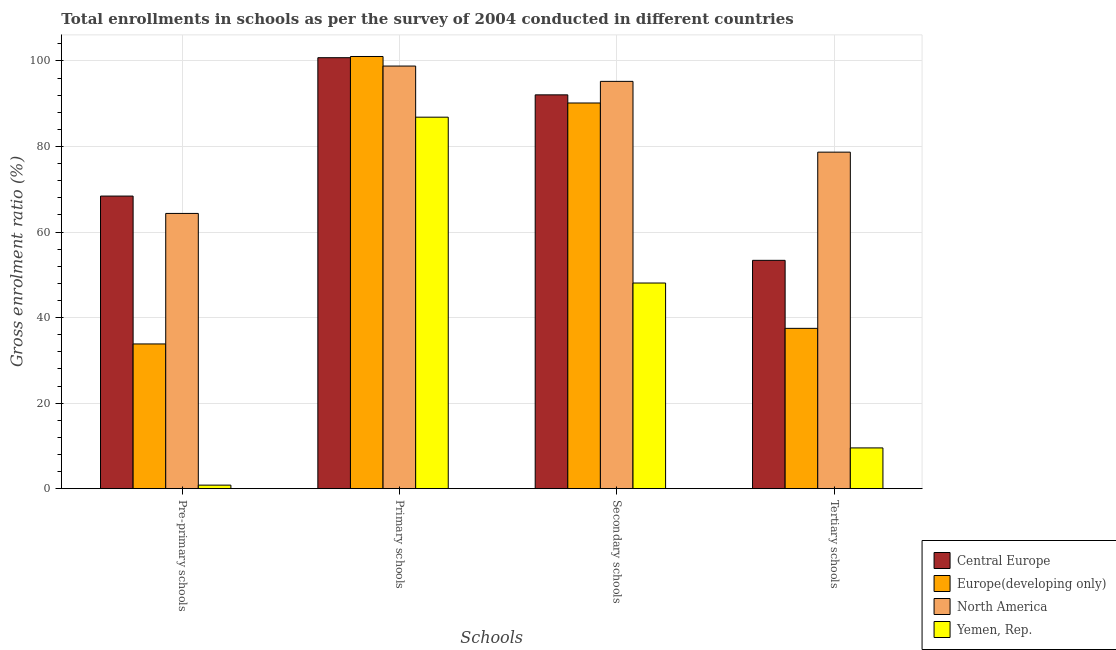How many different coloured bars are there?
Give a very brief answer. 4. Are the number of bars per tick equal to the number of legend labels?
Make the answer very short. Yes. Are the number of bars on each tick of the X-axis equal?
Provide a short and direct response. Yes. How many bars are there on the 2nd tick from the right?
Your answer should be compact. 4. What is the label of the 2nd group of bars from the left?
Your answer should be compact. Primary schools. What is the gross enrolment ratio in tertiary schools in Yemen, Rep.?
Make the answer very short. 9.53. Across all countries, what is the maximum gross enrolment ratio in pre-primary schools?
Ensure brevity in your answer.  68.41. Across all countries, what is the minimum gross enrolment ratio in primary schools?
Your response must be concise. 86.85. In which country was the gross enrolment ratio in primary schools maximum?
Your answer should be compact. Europe(developing only). In which country was the gross enrolment ratio in pre-primary schools minimum?
Your answer should be very brief. Yemen, Rep. What is the total gross enrolment ratio in pre-primary schools in the graph?
Give a very brief answer. 167.42. What is the difference between the gross enrolment ratio in pre-primary schools in Central Europe and that in Yemen, Rep.?
Your response must be concise. 67.58. What is the difference between the gross enrolment ratio in primary schools in Yemen, Rep. and the gross enrolment ratio in tertiary schools in North America?
Offer a very short reply. 8.17. What is the average gross enrolment ratio in pre-primary schools per country?
Offer a very short reply. 41.85. What is the difference between the gross enrolment ratio in secondary schools and gross enrolment ratio in primary schools in Central Europe?
Offer a very short reply. -8.69. In how many countries, is the gross enrolment ratio in secondary schools greater than 84 %?
Your response must be concise. 3. What is the ratio of the gross enrolment ratio in tertiary schools in Europe(developing only) to that in Yemen, Rep.?
Make the answer very short. 3.93. Is the gross enrolment ratio in pre-primary schools in North America less than that in Central Europe?
Your answer should be compact. Yes. What is the difference between the highest and the second highest gross enrolment ratio in tertiary schools?
Ensure brevity in your answer.  25.29. What is the difference between the highest and the lowest gross enrolment ratio in secondary schools?
Your answer should be compact. 47.14. Is it the case that in every country, the sum of the gross enrolment ratio in primary schools and gross enrolment ratio in secondary schools is greater than the sum of gross enrolment ratio in pre-primary schools and gross enrolment ratio in tertiary schools?
Keep it short and to the point. No. How many countries are there in the graph?
Your response must be concise. 4. What is the difference between two consecutive major ticks on the Y-axis?
Offer a very short reply. 20. Does the graph contain grids?
Ensure brevity in your answer.  Yes. How are the legend labels stacked?
Your response must be concise. Vertical. What is the title of the graph?
Make the answer very short. Total enrollments in schools as per the survey of 2004 conducted in different countries. What is the label or title of the X-axis?
Provide a succinct answer. Schools. What is the label or title of the Y-axis?
Keep it short and to the point. Gross enrolment ratio (%). What is the Gross enrolment ratio (%) in Central Europe in Pre-primary schools?
Your answer should be compact. 68.41. What is the Gross enrolment ratio (%) of Europe(developing only) in Pre-primary schools?
Make the answer very short. 33.84. What is the Gross enrolment ratio (%) in North America in Pre-primary schools?
Keep it short and to the point. 64.35. What is the Gross enrolment ratio (%) in Yemen, Rep. in Pre-primary schools?
Keep it short and to the point. 0.83. What is the Gross enrolment ratio (%) in Central Europe in Primary schools?
Provide a succinct answer. 100.76. What is the Gross enrolment ratio (%) in Europe(developing only) in Primary schools?
Your answer should be compact. 101.04. What is the Gross enrolment ratio (%) in North America in Primary schools?
Give a very brief answer. 98.8. What is the Gross enrolment ratio (%) in Yemen, Rep. in Primary schools?
Keep it short and to the point. 86.85. What is the Gross enrolment ratio (%) of Central Europe in Secondary schools?
Provide a succinct answer. 92.07. What is the Gross enrolment ratio (%) of Europe(developing only) in Secondary schools?
Your response must be concise. 90.17. What is the Gross enrolment ratio (%) in North America in Secondary schools?
Make the answer very short. 95.22. What is the Gross enrolment ratio (%) of Yemen, Rep. in Secondary schools?
Provide a succinct answer. 48.08. What is the Gross enrolment ratio (%) of Central Europe in Tertiary schools?
Keep it short and to the point. 53.38. What is the Gross enrolment ratio (%) in Europe(developing only) in Tertiary schools?
Offer a terse response. 37.48. What is the Gross enrolment ratio (%) of North America in Tertiary schools?
Make the answer very short. 78.68. What is the Gross enrolment ratio (%) of Yemen, Rep. in Tertiary schools?
Offer a terse response. 9.53. Across all Schools, what is the maximum Gross enrolment ratio (%) of Central Europe?
Give a very brief answer. 100.76. Across all Schools, what is the maximum Gross enrolment ratio (%) of Europe(developing only)?
Keep it short and to the point. 101.04. Across all Schools, what is the maximum Gross enrolment ratio (%) of North America?
Give a very brief answer. 98.8. Across all Schools, what is the maximum Gross enrolment ratio (%) in Yemen, Rep.?
Give a very brief answer. 86.85. Across all Schools, what is the minimum Gross enrolment ratio (%) of Central Europe?
Provide a succinct answer. 53.38. Across all Schools, what is the minimum Gross enrolment ratio (%) in Europe(developing only)?
Offer a terse response. 33.84. Across all Schools, what is the minimum Gross enrolment ratio (%) in North America?
Keep it short and to the point. 64.35. Across all Schools, what is the minimum Gross enrolment ratio (%) in Yemen, Rep.?
Offer a very short reply. 0.83. What is the total Gross enrolment ratio (%) in Central Europe in the graph?
Your answer should be compact. 314.62. What is the total Gross enrolment ratio (%) of Europe(developing only) in the graph?
Make the answer very short. 262.52. What is the total Gross enrolment ratio (%) of North America in the graph?
Offer a very short reply. 337.05. What is the total Gross enrolment ratio (%) in Yemen, Rep. in the graph?
Your response must be concise. 145.28. What is the difference between the Gross enrolment ratio (%) of Central Europe in Pre-primary schools and that in Primary schools?
Offer a very short reply. -32.35. What is the difference between the Gross enrolment ratio (%) in Europe(developing only) in Pre-primary schools and that in Primary schools?
Give a very brief answer. -67.2. What is the difference between the Gross enrolment ratio (%) of North America in Pre-primary schools and that in Primary schools?
Provide a short and direct response. -34.45. What is the difference between the Gross enrolment ratio (%) of Yemen, Rep. in Pre-primary schools and that in Primary schools?
Your response must be concise. -86.02. What is the difference between the Gross enrolment ratio (%) in Central Europe in Pre-primary schools and that in Secondary schools?
Your response must be concise. -23.66. What is the difference between the Gross enrolment ratio (%) in Europe(developing only) in Pre-primary schools and that in Secondary schools?
Make the answer very short. -56.33. What is the difference between the Gross enrolment ratio (%) in North America in Pre-primary schools and that in Secondary schools?
Give a very brief answer. -30.87. What is the difference between the Gross enrolment ratio (%) of Yemen, Rep. in Pre-primary schools and that in Secondary schools?
Your answer should be compact. -47.25. What is the difference between the Gross enrolment ratio (%) in Central Europe in Pre-primary schools and that in Tertiary schools?
Your response must be concise. 15.02. What is the difference between the Gross enrolment ratio (%) in Europe(developing only) in Pre-primary schools and that in Tertiary schools?
Your answer should be very brief. -3.65. What is the difference between the Gross enrolment ratio (%) in North America in Pre-primary schools and that in Tertiary schools?
Provide a short and direct response. -14.33. What is the difference between the Gross enrolment ratio (%) of Yemen, Rep. in Pre-primary schools and that in Tertiary schools?
Provide a short and direct response. -8.7. What is the difference between the Gross enrolment ratio (%) of Central Europe in Primary schools and that in Secondary schools?
Offer a very short reply. 8.69. What is the difference between the Gross enrolment ratio (%) in Europe(developing only) in Primary schools and that in Secondary schools?
Your response must be concise. 10.87. What is the difference between the Gross enrolment ratio (%) of North America in Primary schools and that in Secondary schools?
Your answer should be very brief. 3.58. What is the difference between the Gross enrolment ratio (%) of Yemen, Rep. in Primary schools and that in Secondary schools?
Provide a short and direct response. 38.77. What is the difference between the Gross enrolment ratio (%) of Central Europe in Primary schools and that in Tertiary schools?
Keep it short and to the point. 47.37. What is the difference between the Gross enrolment ratio (%) in Europe(developing only) in Primary schools and that in Tertiary schools?
Make the answer very short. 63.56. What is the difference between the Gross enrolment ratio (%) in North America in Primary schools and that in Tertiary schools?
Give a very brief answer. 20.13. What is the difference between the Gross enrolment ratio (%) in Yemen, Rep. in Primary schools and that in Tertiary schools?
Provide a short and direct response. 77.32. What is the difference between the Gross enrolment ratio (%) of Central Europe in Secondary schools and that in Tertiary schools?
Make the answer very short. 38.69. What is the difference between the Gross enrolment ratio (%) in Europe(developing only) in Secondary schools and that in Tertiary schools?
Give a very brief answer. 52.68. What is the difference between the Gross enrolment ratio (%) in North America in Secondary schools and that in Tertiary schools?
Your answer should be compact. 16.55. What is the difference between the Gross enrolment ratio (%) of Yemen, Rep. in Secondary schools and that in Tertiary schools?
Offer a terse response. 38.55. What is the difference between the Gross enrolment ratio (%) in Central Europe in Pre-primary schools and the Gross enrolment ratio (%) in Europe(developing only) in Primary schools?
Offer a very short reply. -32.63. What is the difference between the Gross enrolment ratio (%) in Central Europe in Pre-primary schools and the Gross enrolment ratio (%) in North America in Primary schools?
Keep it short and to the point. -30.4. What is the difference between the Gross enrolment ratio (%) in Central Europe in Pre-primary schools and the Gross enrolment ratio (%) in Yemen, Rep. in Primary schools?
Provide a succinct answer. -18.44. What is the difference between the Gross enrolment ratio (%) of Europe(developing only) in Pre-primary schools and the Gross enrolment ratio (%) of North America in Primary schools?
Your response must be concise. -64.97. What is the difference between the Gross enrolment ratio (%) of Europe(developing only) in Pre-primary schools and the Gross enrolment ratio (%) of Yemen, Rep. in Primary schools?
Your response must be concise. -53.01. What is the difference between the Gross enrolment ratio (%) of North America in Pre-primary schools and the Gross enrolment ratio (%) of Yemen, Rep. in Primary schools?
Offer a very short reply. -22.5. What is the difference between the Gross enrolment ratio (%) of Central Europe in Pre-primary schools and the Gross enrolment ratio (%) of Europe(developing only) in Secondary schools?
Provide a succinct answer. -21.76. What is the difference between the Gross enrolment ratio (%) of Central Europe in Pre-primary schools and the Gross enrolment ratio (%) of North America in Secondary schools?
Give a very brief answer. -26.82. What is the difference between the Gross enrolment ratio (%) of Central Europe in Pre-primary schools and the Gross enrolment ratio (%) of Yemen, Rep. in Secondary schools?
Ensure brevity in your answer.  20.33. What is the difference between the Gross enrolment ratio (%) of Europe(developing only) in Pre-primary schools and the Gross enrolment ratio (%) of North America in Secondary schools?
Provide a short and direct response. -61.39. What is the difference between the Gross enrolment ratio (%) in Europe(developing only) in Pre-primary schools and the Gross enrolment ratio (%) in Yemen, Rep. in Secondary schools?
Provide a succinct answer. -14.24. What is the difference between the Gross enrolment ratio (%) of North America in Pre-primary schools and the Gross enrolment ratio (%) of Yemen, Rep. in Secondary schools?
Your answer should be very brief. 16.27. What is the difference between the Gross enrolment ratio (%) of Central Europe in Pre-primary schools and the Gross enrolment ratio (%) of Europe(developing only) in Tertiary schools?
Offer a very short reply. 30.92. What is the difference between the Gross enrolment ratio (%) of Central Europe in Pre-primary schools and the Gross enrolment ratio (%) of North America in Tertiary schools?
Keep it short and to the point. -10.27. What is the difference between the Gross enrolment ratio (%) of Central Europe in Pre-primary schools and the Gross enrolment ratio (%) of Yemen, Rep. in Tertiary schools?
Ensure brevity in your answer.  58.88. What is the difference between the Gross enrolment ratio (%) in Europe(developing only) in Pre-primary schools and the Gross enrolment ratio (%) in North America in Tertiary schools?
Keep it short and to the point. -44.84. What is the difference between the Gross enrolment ratio (%) in Europe(developing only) in Pre-primary schools and the Gross enrolment ratio (%) in Yemen, Rep. in Tertiary schools?
Make the answer very short. 24.31. What is the difference between the Gross enrolment ratio (%) of North America in Pre-primary schools and the Gross enrolment ratio (%) of Yemen, Rep. in Tertiary schools?
Offer a very short reply. 54.82. What is the difference between the Gross enrolment ratio (%) of Central Europe in Primary schools and the Gross enrolment ratio (%) of Europe(developing only) in Secondary schools?
Your response must be concise. 10.59. What is the difference between the Gross enrolment ratio (%) in Central Europe in Primary schools and the Gross enrolment ratio (%) in North America in Secondary schools?
Make the answer very short. 5.54. What is the difference between the Gross enrolment ratio (%) of Central Europe in Primary schools and the Gross enrolment ratio (%) of Yemen, Rep. in Secondary schools?
Offer a very short reply. 52.68. What is the difference between the Gross enrolment ratio (%) of Europe(developing only) in Primary schools and the Gross enrolment ratio (%) of North America in Secondary schools?
Give a very brief answer. 5.82. What is the difference between the Gross enrolment ratio (%) in Europe(developing only) in Primary schools and the Gross enrolment ratio (%) in Yemen, Rep. in Secondary schools?
Your response must be concise. 52.96. What is the difference between the Gross enrolment ratio (%) of North America in Primary schools and the Gross enrolment ratio (%) of Yemen, Rep. in Secondary schools?
Keep it short and to the point. 50.73. What is the difference between the Gross enrolment ratio (%) in Central Europe in Primary schools and the Gross enrolment ratio (%) in Europe(developing only) in Tertiary schools?
Provide a short and direct response. 63.28. What is the difference between the Gross enrolment ratio (%) of Central Europe in Primary schools and the Gross enrolment ratio (%) of North America in Tertiary schools?
Keep it short and to the point. 22.08. What is the difference between the Gross enrolment ratio (%) in Central Europe in Primary schools and the Gross enrolment ratio (%) in Yemen, Rep. in Tertiary schools?
Keep it short and to the point. 91.23. What is the difference between the Gross enrolment ratio (%) of Europe(developing only) in Primary schools and the Gross enrolment ratio (%) of North America in Tertiary schools?
Provide a succinct answer. 22.36. What is the difference between the Gross enrolment ratio (%) in Europe(developing only) in Primary schools and the Gross enrolment ratio (%) in Yemen, Rep. in Tertiary schools?
Your response must be concise. 91.51. What is the difference between the Gross enrolment ratio (%) of North America in Primary schools and the Gross enrolment ratio (%) of Yemen, Rep. in Tertiary schools?
Give a very brief answer. 89.27. What is the difference between the Gross enrolment ratio (%) in Central Europe in Secondary schools and the Gross enrolment ratio (%) in Europe(developing only) in Tertiary schools?
Make the answer very short. 54.59. What is the difference between the Gross enrolment ratio (%) in Central Europe in Secondary schools and the Gross enrolment ratio (%) in North America in Tertiary schools?
Offer a terse response. 13.39. What is the difference between the Gross enrolment ratio (%) of Central Europe in Secondary schools and the Gross enrolment ratio (%) of Yemen, Rep. in Tertiary schools?
Ensure brevity in your answer.  82.54. What is the difference between the Gross enrolment ratio (%) of Europe(developing only) in Secondary schools and the Gross enrolment ratio (%) of North America in Tertiary schools?
Keep it short and to the point. 11.49. What is the difference between the Gross enrolment ratio (%) in Europe(developing only) in Secondary schools and the Gross enrolment ratio (%) in Yemen, Rep. in Tertiary schools?
Your answer should be compact. 80.64. What is the difference between the Gross enrolment ratio (%) of North America in Secondary schools and the Gross enrolment ratio (%) of Yemen, Rep. in Tertiary schools?
Offer a terse response. 85.69. What is the average Gross enrolment ratio (%) of Central Europe per Schools?
Provide a short and direct response. 78.65. What is the average Gross enrolment ratio (%) in Europe(developing only) per Schools?
Offer a terse response. 65.63. What is the average Gross enrolment ratio (%) in North America per Schools?
Your answer should be very brief. 84.26. What is the average Gross enrolment ratio (%) of Yemen, Rep. per Schools?
Provide a succinct answer. 36.32. What is the difference between the Gross enrolment ratio (%) in Central Europe and Gross enrolment ratio (%) in Europe(developing only) in Pre-primary schools?
Ensure brevity in your answer.  34.57. What is the difference between the Gross enrolment ratio (%) of Central Europe and Gross enrolment ratio (%) of North America in Pre-primary schools?
Your response must be concise. 4.06. What is the difference between the Gross enrolment ratio (%) of Central Europe and Gross enrolment ratio (%) of Yemen, Rep. in Pre-primary schools?
Your response must be concise. 67.58. What is the difference between the Gross enrolment ratio (%) of Europe(developing only) and Gross enrolment ratio (%) of North America in Pre-primary schools?
Your response must be concise. -30.51. What is the difference between the Gross enrolment ratio (%) of Europe(developing only) and Gross enrolment ratio (%) of Yemen, Rep. in Pre-primary schools?
Give a very brief answer. 33.01. What is the difference between the Gross enrolment ratio (%) in North America and Gross enrolment ratio (%) in Yemen, Rep. in Pre-primary schools?
Offer a very short reply. 63.52. What is the difference between the Gross enrolment ratio (%) of Central Europe and Gross enrolment ratio (%) of Europe(developing only) in Primary schools?
Keep it short and to the point. -0.28. What is the difference between the Gross enrolment ratio (%) in Central Europe and Gross enrolment ratio (%) in North America in Primary schools?
Give a very brief answer. 1.96. What is the difference between the Gross enrolment ratio (%) in Central Europe and Gross enrolment ratio (%) in Yemen, Rep. in Primary schools?
Ensure brevity in your answer.  13.91. What is the difference between the Gross enrolment ratio (%) in Europe(developing only) and Gross enrolment ratio (%) in North America in Primary schools?
Your answer should be compact. 2.24. What is the difference between the Gross enrolment ratio (%) of Europe(developing only) and Gross enrolment ratio (%) of Yemen, Rep. in Primary schools?
Offer a very short reply. 14.19. What is the difference between the Gross enrolment ratio (%) in North America and Gross enrolment ratio (%) in Yemen, Rep. in Primary schools?
Offer a terse response. 11.95. What is the difference between the Gross enrolment ratio (%) of Central Europe and Gross enrolment ratio (%) of Europe(developing only) in Secondary schools?
Keep it short and to the point. 1.9. What is the difference between the Gross enrolment ratio (%) in Central Europe and Gross enrolment ratio (%) in North America in Secondary schools?
Provide a short and direct response. -3.15. What is the difference between the Gross enrolment ratio (%) of Central Europe and Gross enrolment ratio (%) of Yemen, Rep. in Secondary schools?
Make the answer very short. 43.99. What is the difference between the Gross enrolment ratio (%) in Europe(developing only) and Gross enrolment ratio (%) in North America in Secondary schools?
Give a very brief answer. -5.06. What is the difference between the Gross enrolment ratio (%) of Europe(developing only) and Gross enrolment ratio (%) of Yemen, Rep. in Secondary schools?
Offer a terse response. 42.09. What is the difference between the Gross enrolment ratio (%) in North America and Gross enrolment ratio (%) in Yemen, Rep. in Secondary schools?
Make the answer very short. 47.14. What is the difference between the Gross enrolment ratio (%) in Central Europe and Gross enrolment ratio (%) in Europe(developing only) in Tertiary schools?
Give a very brief answer. 15.9. What is the difference between the Gross enrolment ratio (%) of Central Europe and Gross enrolment ratio (%) of North America in Tertiary schools?
Offer a very short reply. -25.29. What is the difference between the Gross enrolment ratio (%) in Central Europe and Gross enrolment ratio (%) in Yemen, Rep. in Tertiary schools?
Offer a terse response. 43.86. What is the difference between the Gross enrolment ratio (%) in Europe(developing only) and Gross enrolment ratio (%) in North America in Tertiary schools?
Provide a succinct answer. -41.19. What is the difference between the Gross enrolment ratio (%) of Europe(developing only) and Gross enrolment ratio (%) of Yemen, Rep. in Tertiary schools?
Make the answer very short. 27.95. What is the difference between the Gross enrolment ratio (%) in North America and Gross enrolment ratio (%) in Yemen, Rep. in Tertiary schools?
Provide a succinct answer. 69.15. What is the ratio of the Gross enrolment ratio (%) in Central Europe in Pre-primary schools to that in Primary schools?
Offer a very short reply. 0.68. What is the ratio of the Gross enrolment ratio (%) of Europe(developing only) in Pre-primary schools to that in Primary schools?
Provide a succinct answer. 0.33. What is the ratio of the Gross enrolment ratio (%) of North America in Pre-primary schools to that in Primary schools?
Ensure brevity in your answer.  0.65. What is the ratio of the Gross enrolment ratio (%) of Yemen, Rep. in Pre-primary schools to that in Primary schools?
Your answer should be very brief. 0.01. What is the ratio of the Gross enrolment ratio (%) in Central Europe in Pre-primary schools to that in Secondary schools?
Offer a terse response. 0.74. What is the ratio of the Gross enrolment ratio (%) in Europe(developing only) in Pre-primary schools to that in Secondary schools?
Your response must be concise. 0.38. What is the ratio of the Gross enrolment ratio (%) in North America in Pre-primary schools to that in Secondary schools?
Keep it short and to the point. 0.68. What is the ratio of the Gross enrolment ratio (%) of Yemen, Rep. in Pre-primary schools to that in Secondary schools?
Offer a terse response. 0.02. What is the ratio of the Gross enrolment ratio (%) in Central Europe in Pre-primary schools to that in Tertiary schools?
Provide a succinct answer. 1.28. What is the ratio of the Gross enrolment ratio (%) of Europe(developing only) in Pre-primary schools to that in Tertiary schools?
Offer a very short reply. 0.9. What is the ratio of the Gross enrolment ratio (%) of North America in Pre-primary schools to that in Tertiary schools?
Ensure brevity in your answer.  0.82. What is the ratio of the Gross enrolment ratio (%) in Yemen, Rep. in Pre-primary schools to that in Tertiary schools?
Provide a short and direct response. 0.09. What is the ratio of the Gross enrolment ratio (%) in Central Europe in Primary schools to that in Secondary schools?
Provide a succinct answer. 1.09. What is the ratio of the Gross enrolment ratio (%) in Europe(developing only) in Primary schools to that in Secondary schools?
Provide a succinct answer. 1.12. What is the ratio of the Gross enrolment ratio (%) of North America in Primary schools to that in Secondary schools?
Provide a succinct answer. 1.04. What is the ratio of the Gross enrolment ratio (%) in Yemen, Rep. in Primary schools to that in Secondary schools?
Ensure brevity in your answer.  1.81. What is the ratio of the Gross enrolment ratio (%) in Central Europe in Primary schools to that in Tertiary schools?
Make the answer very short. 1.89. What is the ratio of the Gross enrolment ratio (%) of Europe(developing only) in Primary schools to that in Tertiary schools?
Ensure brevity in your answer.  2.7. What is the ratio of the Gross enrolment ratio (%) in North America in Primary schools to that in Tertiary schools?
Your response must be concise. 1.26. What is the ratio of the Gross enrolment ratio (%) of Yemen, Rep. in Primary schools to that in Tertiary schools?
Make the answer very short. 9.11. What is the ratio of the Gross enrolment ratio (%) of Central Europe in Secondary schools to that in Tertiary schools?
Provide a short and direct response. 1.72. What is the ratio of the Gross enrolment ratio (%) of Europe(developing only) in Secondary schools to that in Tertiary schools?
Keep it short and to the point. 2.41. What is the ratio of the Gross enrolment ratio (%) of North America in Secondary schools to that in Tertiary schools?
Provide a succinct answer. 1.21. What is the ratio of the Gross enrolment ratio (%) in Yemen, Rep. in Secondary schools to that in Tertiary schools?
Your response must be concise. 5.05. What is the difference between the highest and the second highest Gross enrolment ratio (%) of Central Europe?
Your response must be concise. 8.69. What is the difference between the highest and the second highest Gross enrolment ratio (%) in Europe(developing only)?
Offer a very short reply. 10.87. What is the difference between the highest and the second highest Gross enrolment ratio (%) in North America?
Provide a short and direct response. 3.58. What is the difference between the highest and the second highest Gross enrolment ratio (%) in Yemen, Rep.?
Your answer should be compact. 38.77. What is the difference between the highest and the lowest Gross enrolment ratio (%) of Central Europe?
Your response must be concise. 47.37. What is the difference between the highest and the lowest Gross enrolment ratio (%) in Europe(developing only)?
Make the answer very short. 67.2. What is the difference between the highest and the lowest Gross enrolment ratio (%) of North America?
Offer a terse response. 34.45. What is the difference between the highest and the lowest Gross enrolment ratio (%) of Yemen, Rep.?
Keep it short and to the point. 86.02. 